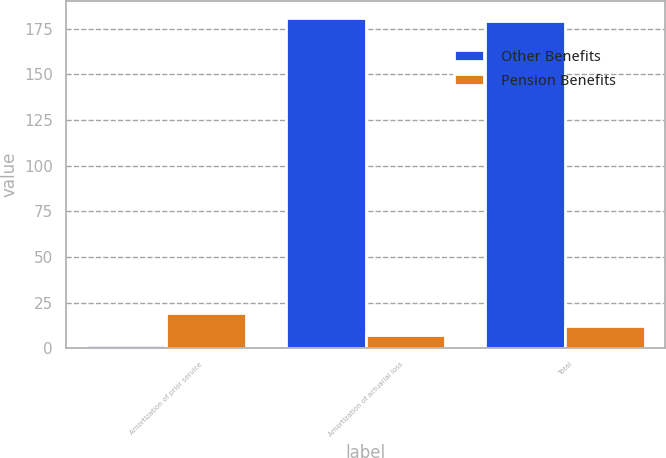<chart> <loc_0><loc_0><loc_500><loc_500><stacked_bar_chart><ecel><fcel>Amortization of prior service<fcel>Amortization of actuarial loss<fcel>Total<nl><fcel>Other Benefits<fcel>2<fcel>181<fcel>179<nl><fcel>Pension Benefits<fcel>19<fcel>7<fcel>12<nl></chart> 